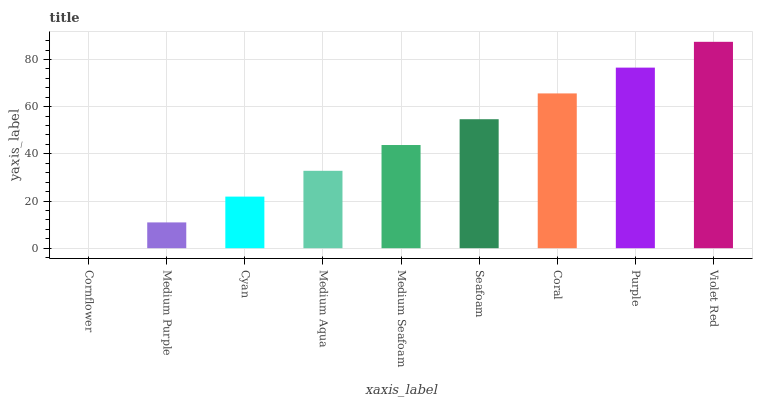Is Cornflower the minimum?
Answer yes or no. Yes. Is Violet Red the maximum?
Answer yes or no. Yes. Is Medium Purple the minimum?
Answer yes or no. No. Is Medium Purple the maximum?
Answer yes or no. No. Is Medium Purple greater than Cornflower?
Answer yes or no. Yes. Is Cornflower less than Medium Purple?
Answer yes or no. Yes. Is Cornflower greater than Medium Purple?
Answer yes or no. No. Is Medium Purple less than Cornflower?
Answer yes or no. No. Is Medium Seafoam the high median?
Answer yes or no. Yes. Is Medium Seafoam the low median?
Answer yes or no. Yes. Is Medium Aqua the high median?
Answer yes or no. No. Is Medium Purple the low median?
Answer yes or no. No. 